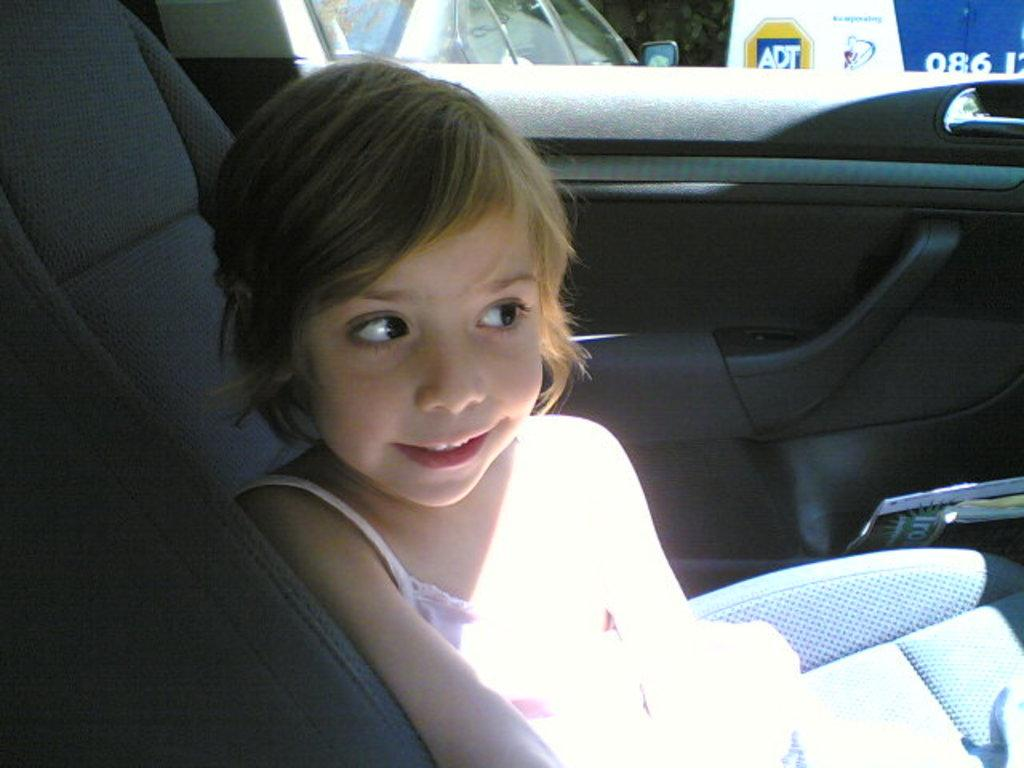Who is the main subject in the image? There is a girl in the image. What is the girl doing in the image? The girl is sitting in a car. What type of test is the girl taking in the image? There is no indication in the image that the girl is taking a test; she is simply sitting in a car. 